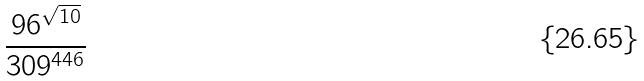<formula> <loc_0><loc_0><loc_500><loc_500>\frac { 9 6 ^ { \sqrt { 1 0 } } } { 3 0 9 ^ { 4 4 6 } }</formula> 